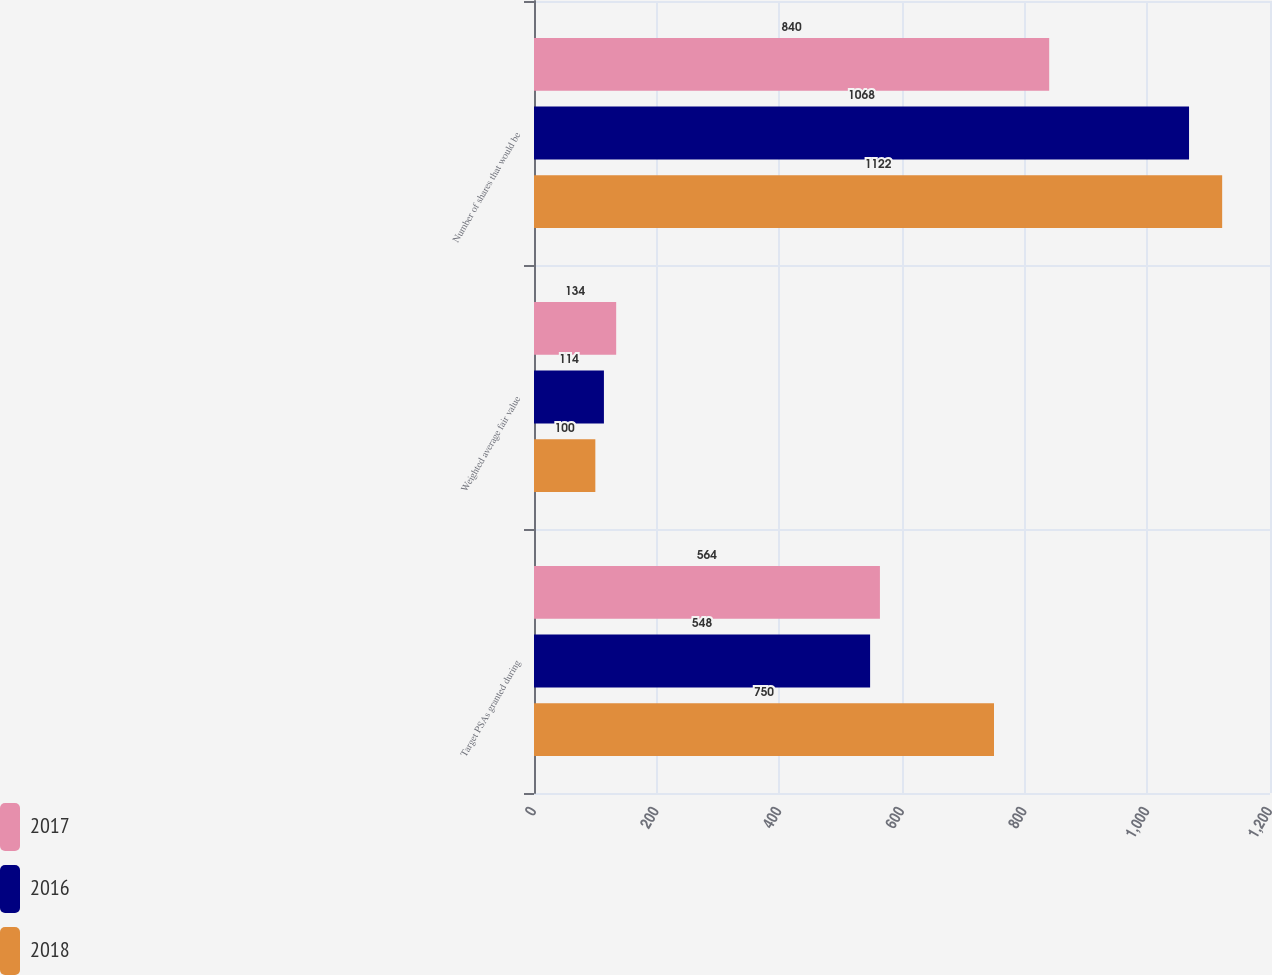Convert chart to OTSL. <chart><loc_0><loc_0><loc_500><loc_500><stacked_bar_chart><ecel><fcel>Target PSAs granted during<fcel>Weighted average fair value<fcel>Number of shares that would be<nl><fcel>2017<fcel>564<fcel>134<fcel>840<nl><fcel>2016<fcel>548<fcel>114<fcel>1068<nl><fcel>2018<fcel>750<fcel>100<fcel>1122<nl></chart> 